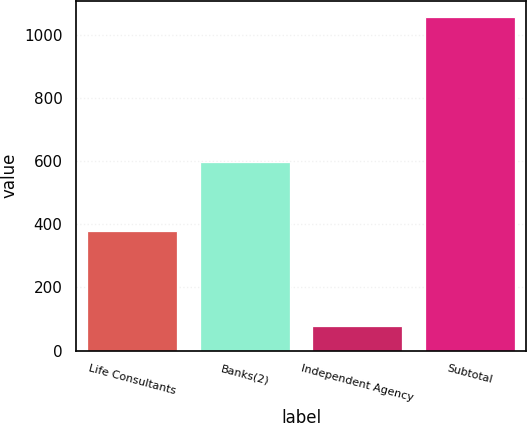Convert chart. <chart><loc_0><loc_0><loc_500><loc_500><bar_chart><fcel>Life Consultants<fcel>Banks(2)<fcel>Independent Agency<fcel>Subtotal<nl><fcel>379<fcel>598<fcel>78<fcel>1055<nl></chart> 